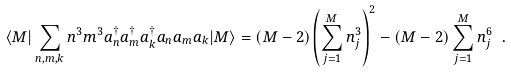Convert formula to latex. <formula><loc_0><loc_0><loc_500><loc_500>\langle M | \sum _ { n , m , k } n ^ { 3 } m ^ { 3 } a _ { n } ^ { \dagger } a _ { m } ^ { \dagger } a _ { k } ^ { \dagger } a _ { n } a _ { m } a _ { k } | M \rangle = ( M - 2 ) \left ( \sum _ { j = 1 } ^ { M } n _ { j } ^ { 3 } \right ) ^ { 2 } - ( M - 2 ) \sum _ { j = 1 } ^ { M } n _ { j } ^ { 6 } \ .</formula> 